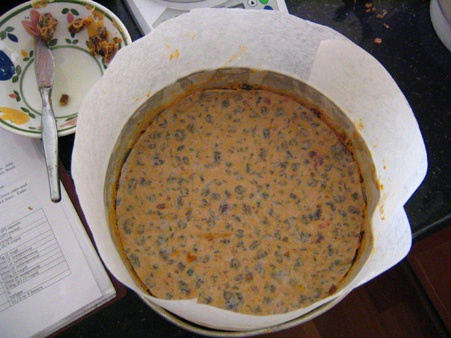Describe the objects in this image and their specific colors. I can see bowl in black, gray, olive, darkgray, and lightgray tones, cake in black, gray, and olive tones, dining table in black, navy, gray, and maroon tones, book in black, darkgray, and lightgray tones, and bowl in black, darkgray, and gray tones in this image. 